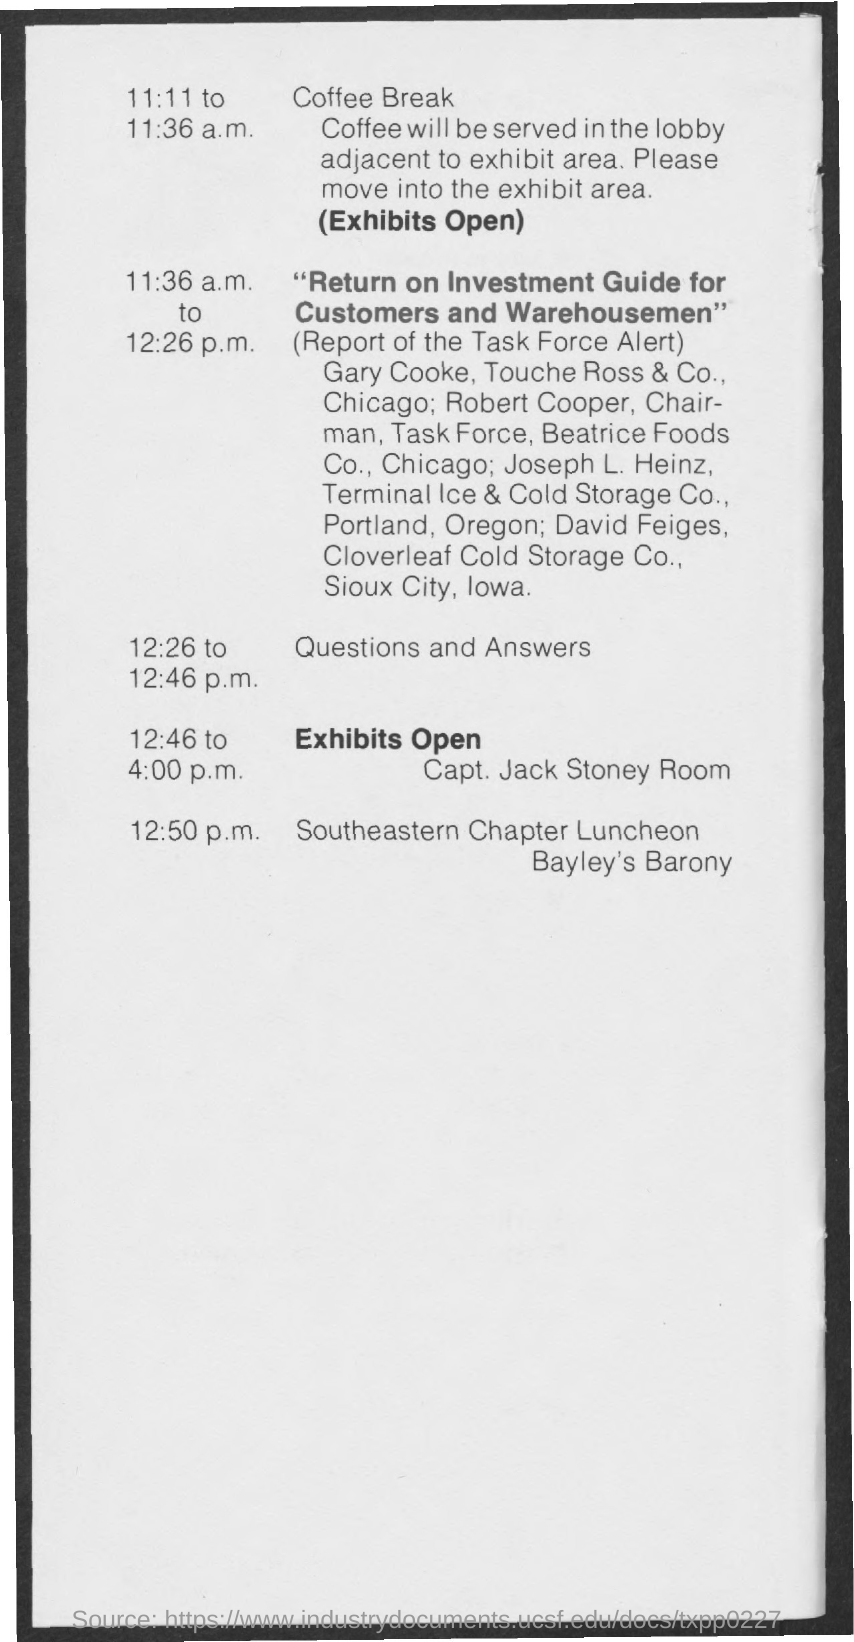Mention a couple of crucial points in this snapshot. The coffee will be served in the lobby adjacent to the exhibit area. The question and answer session will take place between 12:26 p.m. and 12:46 p.m... The coffee break will take place from 11:11 a.m. to 11:36 a.m. At 12:50 p.m., the Southeastern Chapter Luncheon was taking place. 